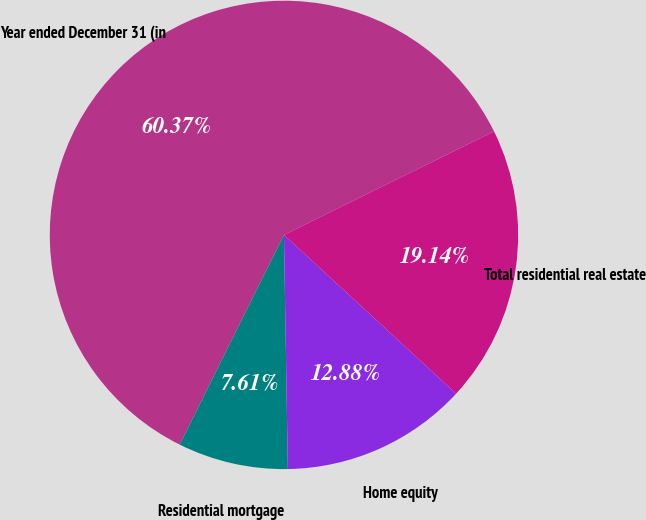<chart> <loc_0><loc_0><loc_500><loc_500><pie_chart><fcel>Year ended December 31 (in<fcel>Residential mortgage<fcel>Home equity<fcel>Total residential real estate<nl><fcel>60.37%<fcel>7.61%<fcel>12.88%<fcel>19.14%<nl></chart> 